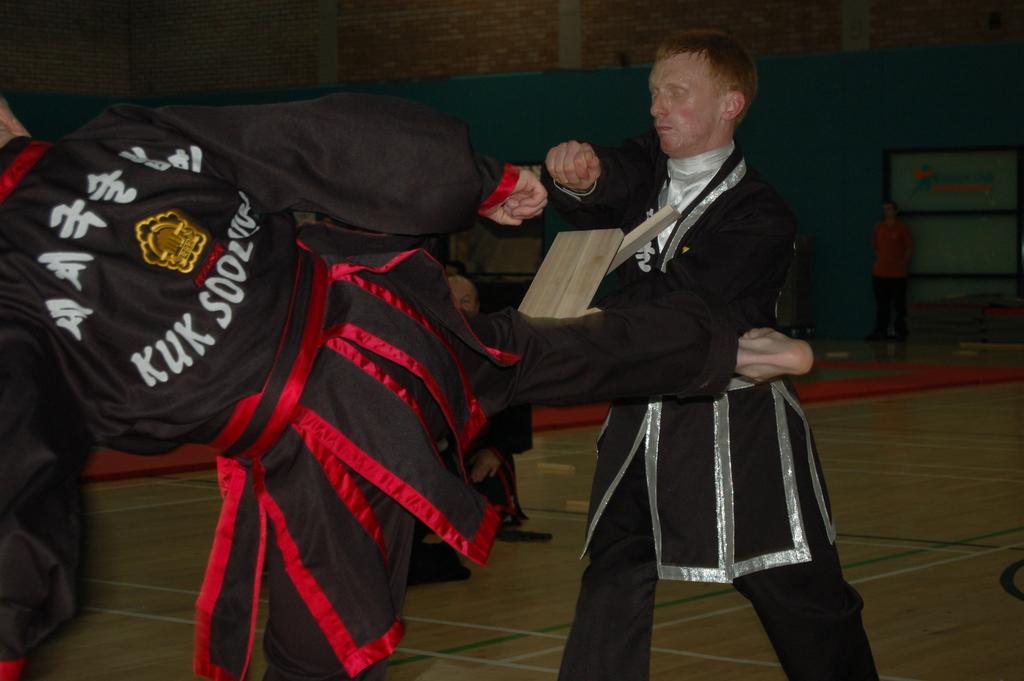What is the first word on the bottom of this guys uniform?
Offer a very short reply. Kuk. 